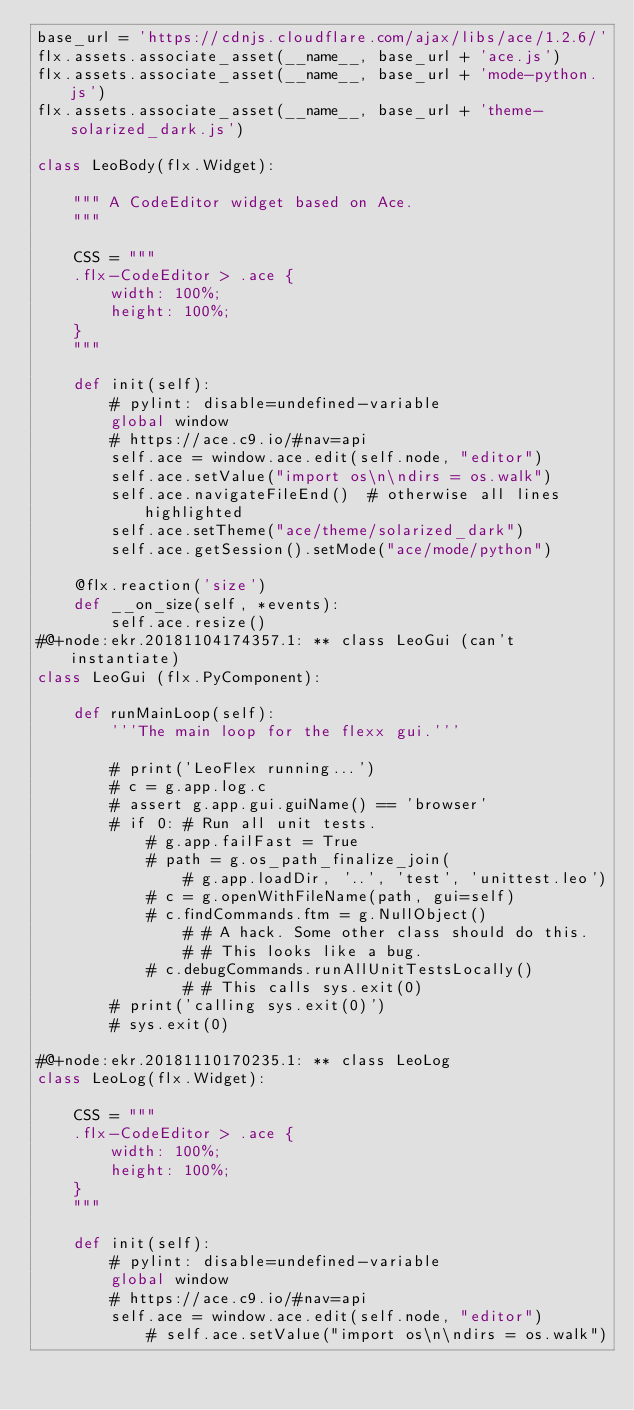<code> <loc_0><loc_0><loc_500><loc_500><_Python_>base_url = 'https://cdnjs.cloudflare.com/ajax/libs/ace/1.2.6/'
flx.assets.associate_asset(__name__, base_url + 'ace.js')
flx.assets.associate_asset(__name__, base_url + 'mode-python.js')
flx.assets.associate_asset(__name__, base_url + 'theme-solarized_dark.js')

class LeoBody(flx.Widget):
    
    """ A CodeEditor widget based on Ace.
    """

    CSS = """
    .flx-CodeEditor > .ace {
        width: 100%;
        height: 100%;
    }
    """

    def init(self):
        # pylint: disable=undefined-variable
        global window
        # https://ace.c9.io/#nav=api
        self.ace = window.ace.edit(self.node, "editor")
        self.ace.setValue("import os\n\ndirs = os.walk")
        self.ace.navigateFileEnd()  # otherwise all lines highlighted
        self.ace.setTheme("ace/theme/solarized_dark")
        self.ace.getSession().setMode("ace/mode/python")

    @flx.reaction('size')
    def __on_size(self, *events):
        self.ace.resize()
#@+node:ekr.20181104174357.1: ** class LeoGui (can't instantiate)
class LeoGui (flx.PyComponent):
    
    def runMainLoop(self):
        '''The main loop for the flexx gui.'''

        # print('LeoFlex running...')
        # c = g.app.log.c
        # assert g.app.gui.guiName() == 'browser'
        # if 0: # Run all unit tests.
            # g.app.failFast = True
            # path = g.os_path_finalize_join(
                # g.app.loadDir, '..', 'test', 'unittest.leo')
            # c = g.openWithFileName(path, gui=self)
            # c.findCommands.ftm = g.NullObject()
                # # A hack. Some other class should do this.
                # # This looks like a bug.
            # c.debugCommands.runAllUnitTestsLocally()
                # # This calls sys.exit(0)
        # print('calling sys.exit(0)')
        # sys.exit(0)
        
#@+node:ekr.20181110170235.1: ** class LeoLog
class LeoLog(flx.Widget):

    CSS = """
    .flx-CodeEditor > .ace {
        width: 100%;
        height: 100%;
    }
    """

    def init(self):
        # pylint: disable=undefined-variable
        global window
        # https://ace.c9.io/#nav=api
        self.ace = window.ace.edit(self.node, "editor")
            # self.ace.setValue("import os\n\ndirs = os.walk")</code> 